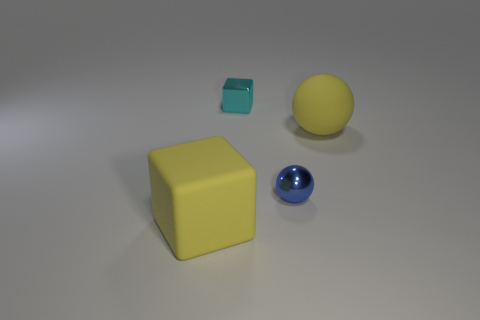Are there any yellow things made of the same material as the tiny sphere?
Make the answer very short. No. The blue thing has what shape?
Ensure brevity in your answer.  Sphere. Is the cyan block the same size as the rubber ball?
Provide a short and direct response. No. There is a matte object that is in front of the blue shiny ball; what shape is it?
Give a very brief answer. Cube. Is the shape of the large thing that is right of the small cyan metallic block the same as the yellow matte object in front of the small metal sphere?
Ensure brevity in your answer.  No. Are there an equal number of big yellow rubber balls that are left of the small blue shiny thing and cyan shiny blocks?
Keep it short and to the point. No. Are there any other things that have the same size as the yellow matte block?
Provide a short and direct response. Yes. What is the material of the other big object that is the same shape as the blue metallic object?
Your response must be concise. Rubber. There is a rubber object on the right side of the yellow cube that is to the left of the tiny blue ball; what shape is it?
Give a very brief answer. Sphere. Is the material of the big yellow object in front of the tiny blue object the same as the cyan block?
Your response must be concise. No. 